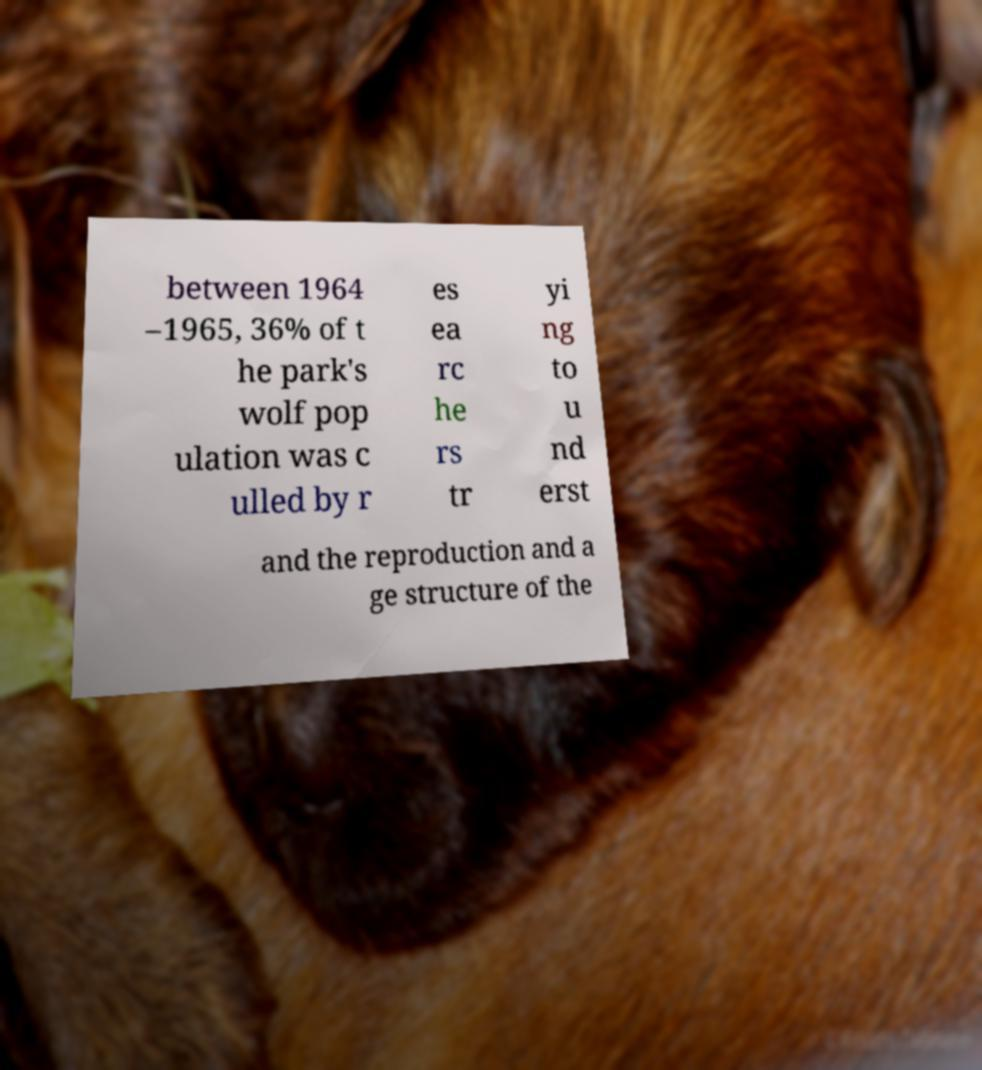I need the written content from this picture converted into text. Can you do that? between 1964 –1965, 36% of t he park's wolf pop ulation was c ulled by r es ea rc he rs tr yi ng to u nd erst and the reproduction and a ge structure of the 